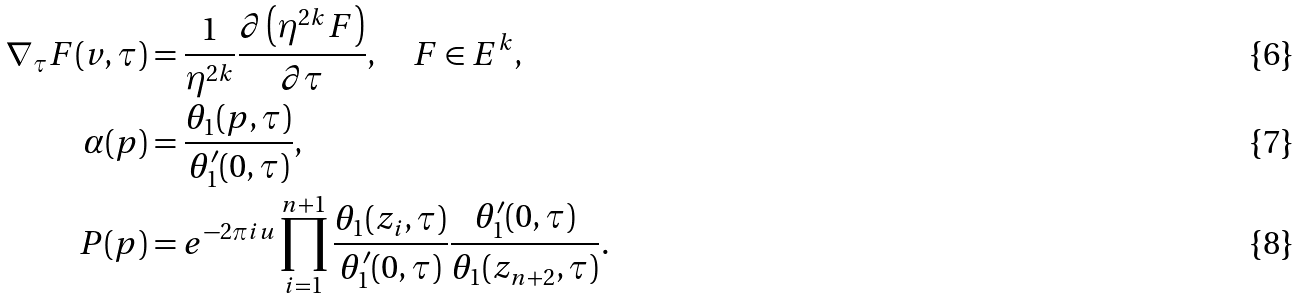Convert formula to latex. <formula><loc_0><loc_0><loc_500><loc_500>\nabla _ { \tau } F ( v , \tau ) & = \frac { 1 } { \eta ^ { 2 k } } \frac { \partial \left ( \eta ^ { 2 k } F \right ) } { \partial \tau } , \quad F \in E ^ { k } , \\ \alpha ( p ) & = \frac { \theta _ { 1 } ( p , \tau ) } { \theta _ { 1 } ^ { \prime } ( 0 , \tau ) } , \\ P ( p ) & = e ^ { - 2 \pi i u } \prod _ { i = 1 } ^ { n + 1 } \frac { \theta _ { 1 } ( z _ { i } , \tau ) } { \theta _ { 1 } ^ { \prime } ( 0 , \tau ) } \frac { \theta _ { 1 } ^ { \prime } ( 0 , \tau ) } { \theta _ { 1 } ( z _ { n + 2 } , \tau ) } .</formula> 